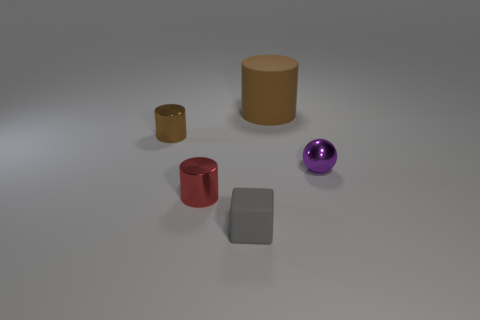There is another metallic cylinder that is the same color as the big cylinder; what is its size?
Your answer should be very brief. Small. How many things are either large brown matte cylinders or spheres?
Your response must be concise. 2. What shape is the small metal object that is both left of the tiny gray matte cube and in front of the tiny brown metal cylinder?
Offer a very short reply. Cylinder. Does the big brown thing have the same shape as the brown thing on the left side of the small block?
Offer a terse response. Yes. There is a large matte cylinder; are there any balls on the left side of it?
Keep it short and to the point. No. What is the material of the cylinder that is the same color as the big thing?
Your answer should be compact. Metal. What number of cubes are small brown objects or red objects?
Give a very brief answer. 0. Is the shape of the small purple object the same as the gray rubber object?
Offer a terse response. No. There is a sphere to the right of the small gray cube; what size is it?
Offer a terse response. Small. Is there a tiny metal thing that has the same color as the cube?
Offer a very short reply. No. 